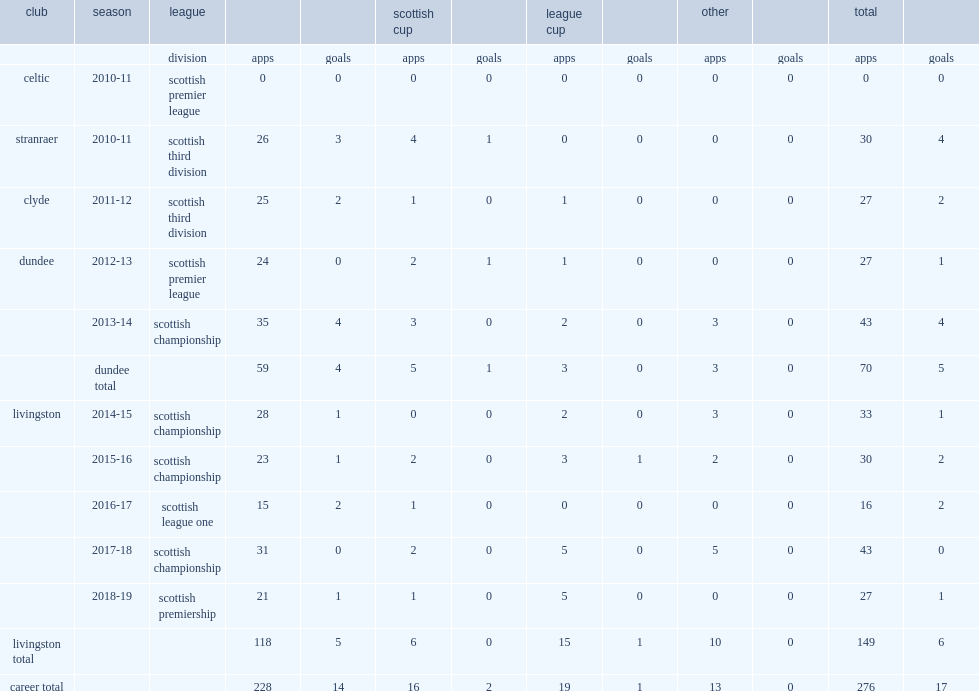What was the number of league appearances made by declan gallagher for livingston in 2016-17? 15.0. 